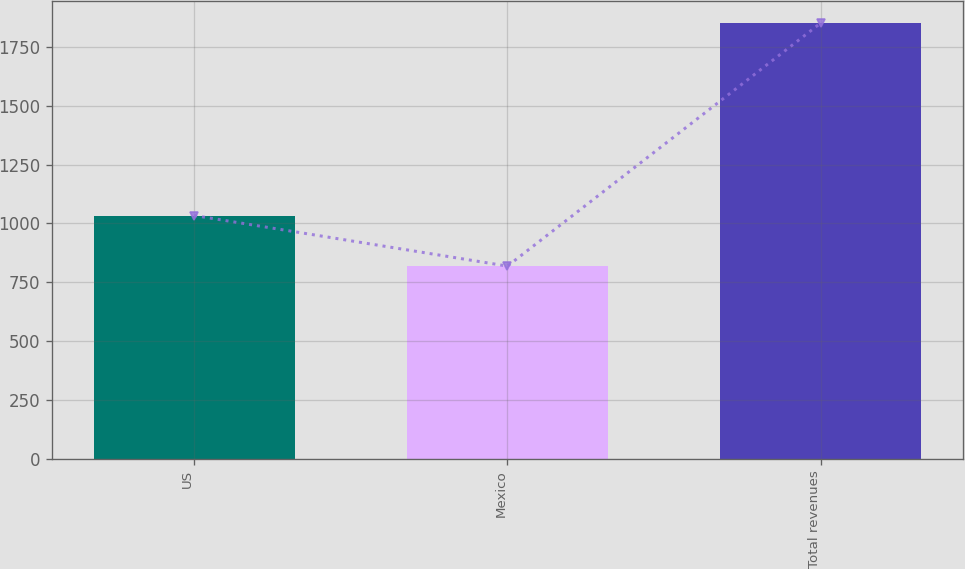Convert chart. <chart><loc_0><loc_0><loc_500><loc_500><bar_chart><fcel>US<fcel>Mexico<fcel>Total revenues<nl><fcel>1033.6<fcel>818.5<fcel>1852.1<nl></chart> 